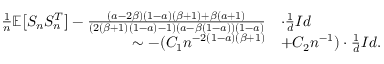Convert formula to latex. <formula><loc_0><loc_0><loc_500><loc_500>\begin{array} { r l } { \frac { 1 } { n } \mathbb { E } \left [ S _ { n } S _ { n } ^ { T } \right ] - \frac { ( a - 2 \beta ) ( 1 - a ) ( \beta + 1 ) + \beta ( a + 1 ) } { ( 2 ( \beta + 1 ) ( 1 - a ) - 1 ) ( a - \beta ( 1 - a ) ) ( 1 - a ) } } & { \cdot \frac { 1 } { d } I d } \\ { \sim - ( C _ { 1 } n ^ { - 2 ( 1 - a ) ( \beta + 1 ) } } & { + C _ { 2 } n ^ { - 1 } ) \cdot \frac { 1 } { d } I d . \quad } \end{array}</formula> 